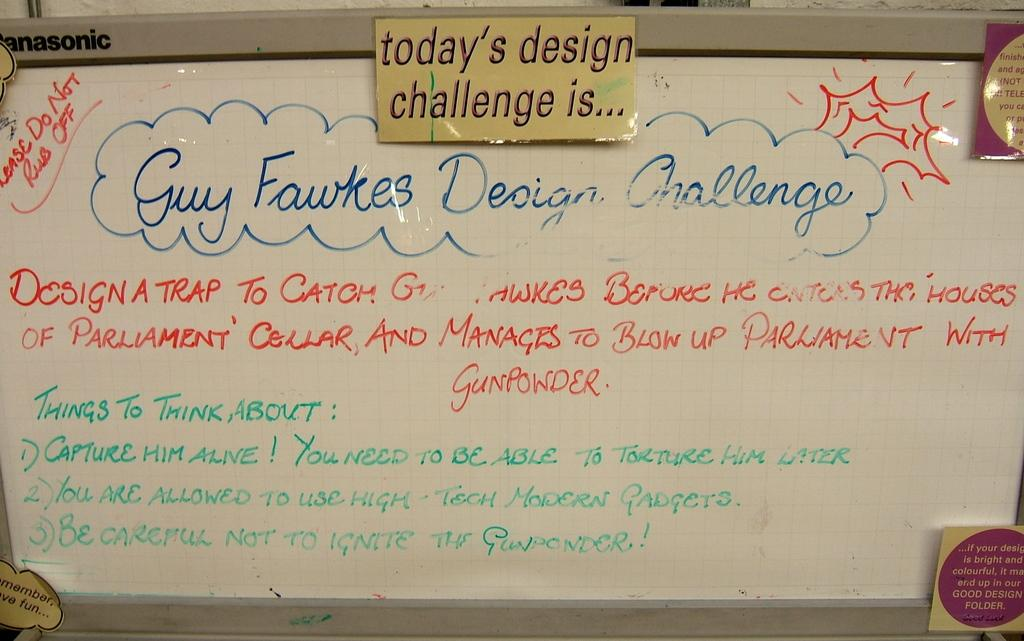<image>
Summarize the visual content of the image. A sign says that today's design challenge is about Guy Fawkes. 